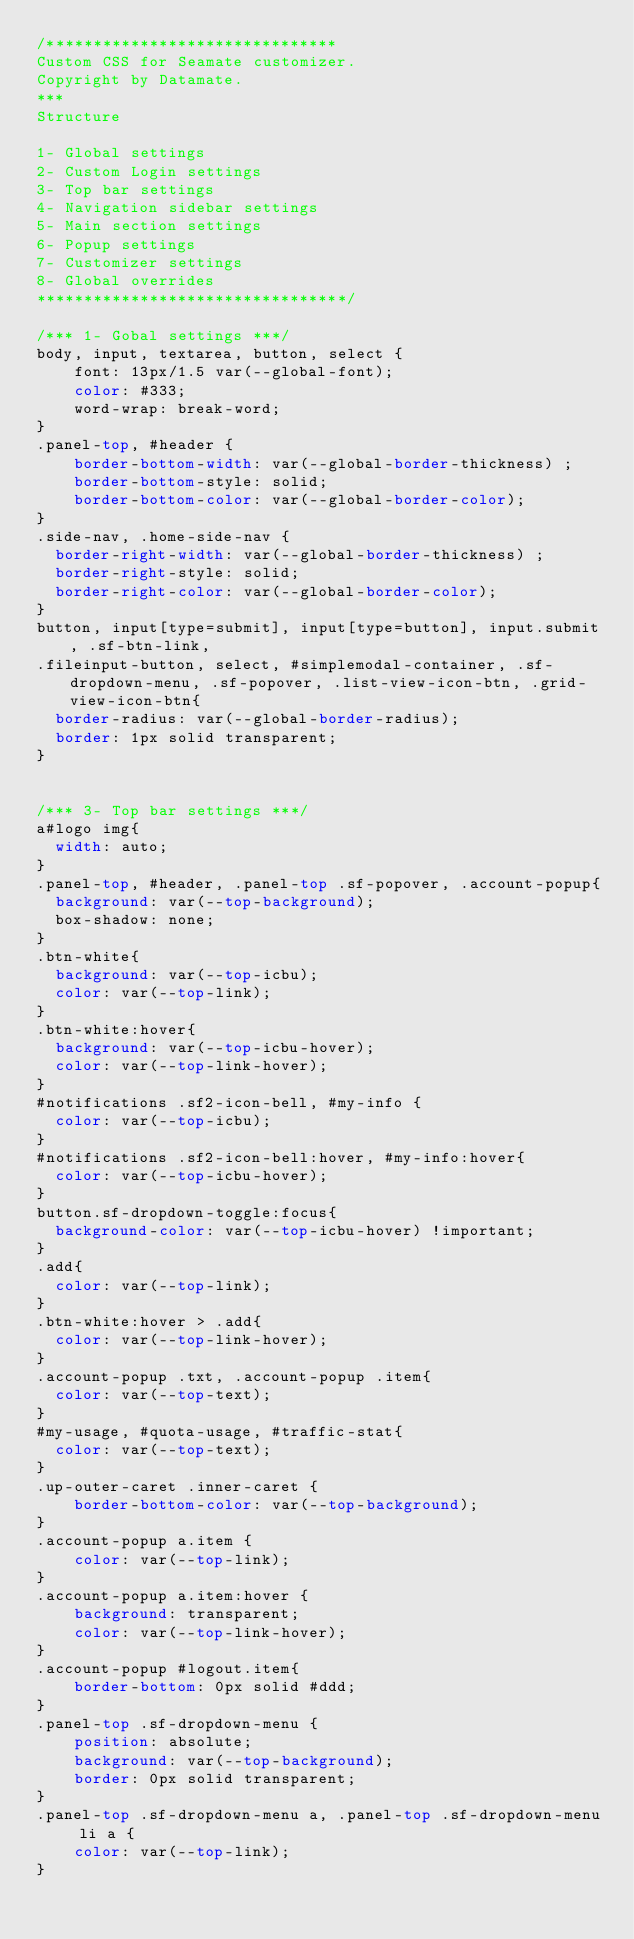<code> <loc_0><loc_0><loc_500><loc_500><_CSS_>/*******************************
Custom CSS for Seamate customizer.
Copyright by Datamate.
***
Structure

1- Global settings
2- Custom Login settings
3- Top bar settings
4- Navigation sidebar settings
5- Main section settings
6- Popup settings
7- Customizer settings
8- Global overrides
*********************************/

/*** 1- Gobal settings ***/
body, input, textarea, button, select {
    font: 13px/1.5 var(--global-font);
    color: #333;
    word-wrap: break-word;
}
.panel-top, #header {
    border-bottom-width: var(--global-border-thickness) ;
    border-bottom-style: solid;
    border-bottom-color: var(--global-border-color);
}
.side-nav, .home-side-nav {
  border-right-width: var(--global-border-thickness) ;
  border-right-style: solid;
  border-right-color: var(--global-border-color);
}
button, input[type=submit], input[type=button], input.submit, .sf-btn-link,
.fileinput-button, select, #simplemodal-container, .sf-dropdown-menu, .sf-popover, .list-view-icon-btn, .grid-view-icon-btn{
  border-radius: var(--global-border-radius);
  border: 1px solid transparent;
}


/*** 3- Top bar settings ***/
a#logo img{
  width: auto;
}
.panel-top, #header, .panel-top .sf-popover, .account-popup{
  background: var(--top-background);
  box-shadow: none;
}
.btn-white{
  background: var(--top-icbu);
  color: var(--top-link);
}
.btn-white:hover{
  background: var(--top-icbu-hover);
  color: var(--top-link-hover);
}
#notifications .sf2-icon-bell, #my-info {
  color: var(--top-icbu);
}
#notifications .sf2-icon-bell:hover, #my-info:hover{
  color: var(--top-icbu-hover);
}
button.sf-dropdown-toggle:focus{
  background-color: var(--top-icbu-hover) !important;
}
.add{
  color: var(--top-link);
}
.btn-white:hover > .add{
  color: var(--top-link-hover);
}
.account-popup .txt, .account-popup .item{
  color: var(--top-text);
}
#my-usage, #quota-usage, #traffic-stat{
  color: var(--top-text);
}
.up-outer-caret .inner-caret {
    border-bottom-color: var(--top-background);
}
.account-popup a.item {
    color: var(--top-link);
}
.account-popup a.item:hover {
    background: transparent;
    color: var(--top-link-hover);
}
.account-popup #logout.item{
    border-bottom: 0px solid #ddd;
}
.panel-top .sf-dropdown-menu {
    position: absolute;
    background: var(--top-background);
    border: 0px solid transparent;
}
.panel-top .sf-dropdown-menu a, .panel-top .sf-dropdown-menu li a {
    color: var(--top-link);
}</code> 